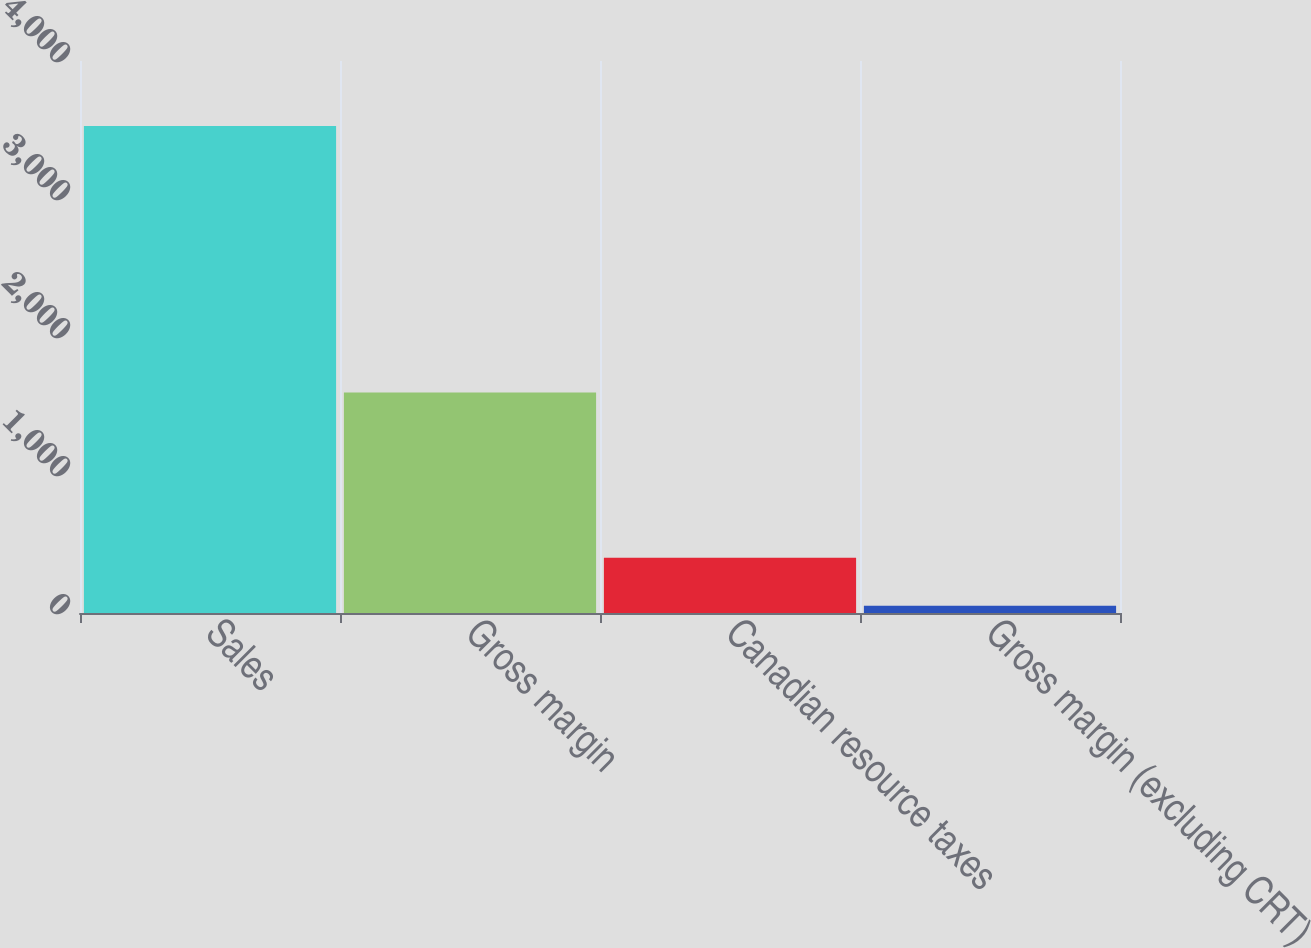Convert chart. <chart><loc_0><loc_0><loc_500><loc_500><bar_chart><fcel>Sales<fcel>Gross margin<fcel>Canadian resource taxes<fcel>Gross margin (excluding CRT)<nl><fcel>3529.3<fcel>1598<fcel>400.09<fcel>52.4<nl></chart> 